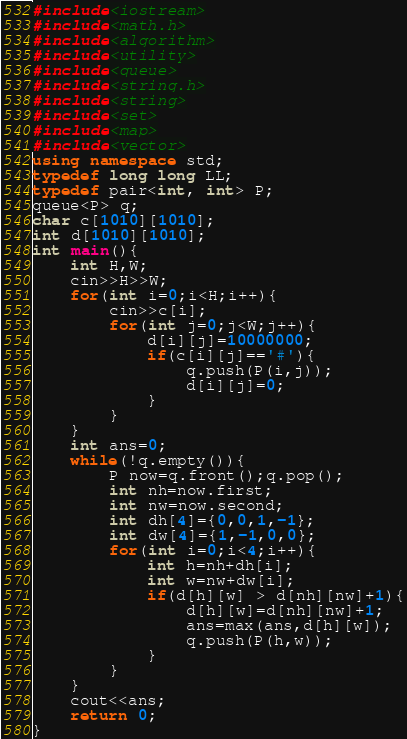Convert code to text. <code><loc_0><loc_0><loc_500><loc_500><_C++_>#include<iostream>
#include<math.h>
#include<algorithm>
#include<utility>
#include<queue>
#include<string.h>
#include<string>
#include<set>
#include<map>
#include<vector>
using namespace std;
typedef long long LL;
typedef pair<int, int> P;
queue<P> q;
char c[1010][1010];
int d[1010][1010];
int main(){
    int H,W;
    cin>>H>>W;
    for(int i=0;i<H;i++){
        cin>>c[i];
        for(int j=0;j<W;j++){
            d[i][j]=10000000;
            if(c[i][j]=='#'){
                q.push(P(i,j));
                d[i][j]=0;
            }
        }
    }
    int ans=0;
    while(!q.empty()){
        P now=q.front();q.pop();
        int nh=now.first;
        int nw=now.second;
        int dh[4]={0,0,1,-1};
        int dw[4]={1,-1,0,0};
        for(int i=0;i<4;i++){
            int h=nh+dh[i];
            int w=nw+dw[i];
            if(d[h][w] > d[nh][nw]+1){
                d[h][w]=d[nh][nw]+1;
                ans=max(ans,d[h][w]);
                q.push(P(h,w));
            }
        }
    }
    cout<<ans;
    return 0;
}</code> 